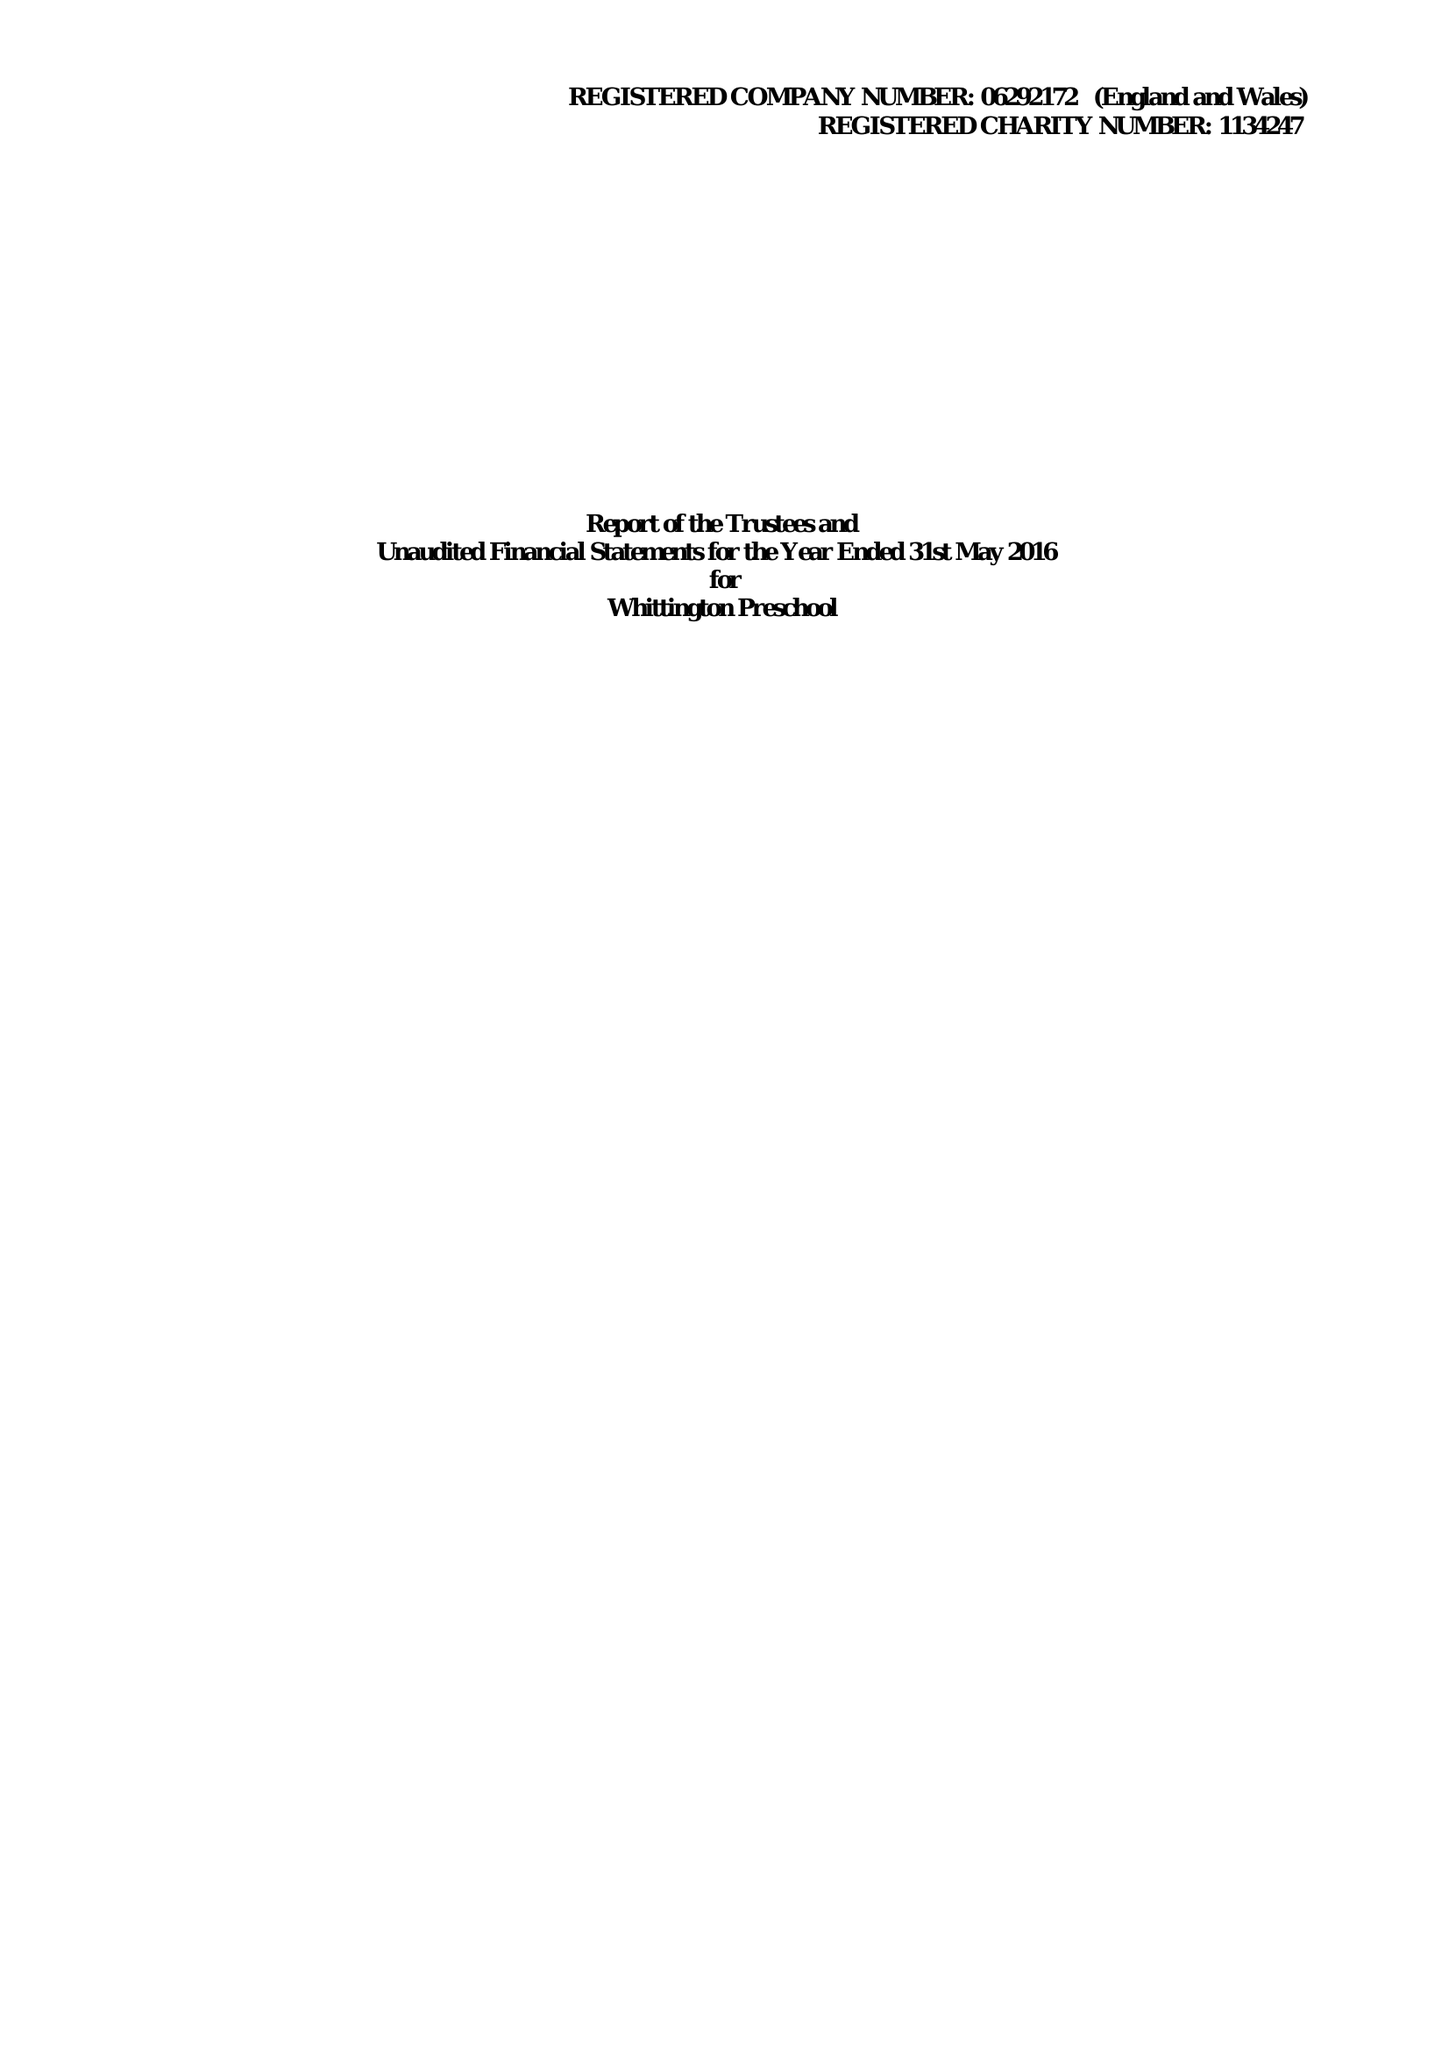What is the value for the spending_annually_in_british_pounds?
Answer the question using a single word or phrase. 251085.00 